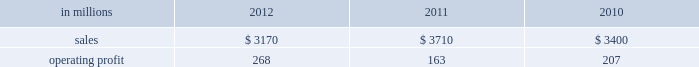Freesheet paper were higher in russia , but lower in europe reflecting weak economic conditions and market demand .
Average sales price realizations for pulp decreased .
Lower input costs for wood and purchased fiber were partially offset by higher costs for energy , chemicals and packaging .
Freight costs were also higher .
Planned maintenance downtime costs were higher due to executing a significant once-every-ten-years maintenance outage plus the regularly scheduled 18-month outage at the saillat mill while outage costs in russia and poland were lower .
Manufacturing operating costs were favor- entering 2013 , sales volumes in the first quarter are expected to be seasonally weaker in russia , but about flat in europe .
Average sales price realizations for uncoated freesheet paper are expected to decrease in europe , but increase in russia .
Input costs should be higher in russia , especially for wood and energy , but be slightly lower in europe .
No maintenance outages are scheduled for the first quarter .
Ind ian papers includes the results of andhra pradesh paper mills ( appm ) of which a 75% ( 75 % ) interest was acquired on october 14 , 2011 .
Net sales were $ 185 million in 2012 and $ 35 million in 2011 .
Operat- ing profits were a loss of $ 16 million in 2012 and a loss of $ 3 million in 2011 .
Asian pr int ing papers net sales were $ 85 mil- lion in 2012 , $ 75 million in 2011 and $ 80 million in 2010 .
Operating profits were improved from break- even in past years to $ 1 million in 2012 .
U.s .
Pulp net sales were $ 725 million in 2012 compared with $ 725 million in 2011 and $ 715 million in 2010 .
Operating profits were a loss of $ 59 million in 2012 compared with gains of $ 87 million in 2011 and $ 107 million in 2010 .
Sales volumes in 2012 increased from 2011 primarily due to the start-up of pulp production at the franklin mill in the third quarter of 2012 .
Average sales price realizations were significantly lower for both fluff pulp and market pulp .
Input costs were lower , primarily for wood and energy .
Freight costs were slightly lower .
Mill operating costs were unfavorable primarily due to costs associated with the start-up of the franklin mill .
Planned maintenance downtime costs were lower .
In the first quarter of 2013 , sales volumes are expected to be flat with the fourth quarter of 2012 .
Average sales price realizations are expected to improve reflecting the realization of sales price increases for paper and tissue pulp that were announced in the fourth quarter of 2012 .
Input costs should be flat .
Planned maintenance downtime costs should be about $ 9 million higher than in the fourth quarter of 2012 .
Manufacturing costs related to the franklin mill should be lower as we continue to improve operations .
Consumer packaging demand and pricing for consumer packaging prod- ucts correlate closely with consumer spending and general economic activity .
In addition to prices and volumes , major factors affecting the profitability of consumer packaging are raw material and energy costs , freight costs , manufacturing efficiency and product mix .
Consumer packaging net sales in 2012 decreased 15% ( 15 % ) from 2011 and 7% ( 7 % ) from 2010 .
Operating profits increased 64% ( 64 % ) from 2011 and 29% ( 29 % ) from 2010 .
Net sales and operating profits include the shorewood business in 2011 and 2010 .
Exclud- ing asset impairment and other charges associated with the sale of the shorewood business , and facility closure costs , 2012 operating profits were 27% ( 27 % ) lower than in 2011 , but 23% ( 23 % ) higher than in 2010 .
Benefits from lower raw material costs ( $ 22 million ) , lower maintenance outage costs ( $ 5 million ) and other items ( $ 2 million ) were more than offset by lower sales price realizations and an unfavorable product mix ( $ 66 million ) , lower sales volumes and increased market-related downtime ( $ 22 million ) , and higher operating costs ( $ 40 million ) .
In addition , operating profits in 2012 included a gain of $ 3 million related to the sale of the shorewood business while operating profits in 2011 included a $ 129 million fixed asset impairment charge for the north ameri- can shorewood business and $ 72 million for other charges associated with the sale of the shorewood business .
Consumer packaging .
North american consumer packaging net sales were $ 2.0 billion in 2012 compared with $ 2.5 billion in 2011 and $ 2.4 billion in 2010 .
Operating profits were $ 165 million ( $ 162 million excluding a gain related to the sale of the shorewood business ) in 2012 compared with $ 35 million ( $ 236 million excluding asset impairment and other charges asso- ciated with the sale of the shorewood business ) in 2011 and $ 97 million ( $ 105 million excluding facility closure costs ) in 2010 .
Coated paperboard sales volumes in 2012 were lower than in 2011 reflecting weaker market demand .
Average sales price realizations were lower , primar- ily for folding carton board .
Input costs for wood increased , but were partially offset by lower costs for chemicals and energy .
Planned maintenance down- time costs were slightly lower .
Market-related down- time was about 113000 tons in 2012 compared with about 38000 tons in 2011. .
What percentage where north american consumer packaging net sales of total consumer packaging sales in 2011? 
Computations: ((2.5 * 1000) / 3710)
Answer: 0.67385. 